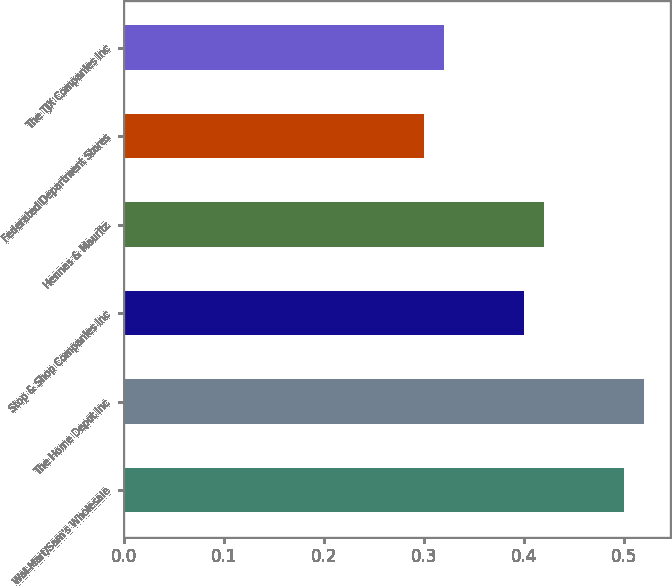<chart> <loc_0><loc_0><loc_500><loc_500><bar_chart><fcel>Wal-Mart/Sam's Wholesale<fcel>The Home Depot Inc<fcel>Stop & Shop Companies Inc<fcel>Hennes & Mauritz<fcel>Federated Department Stores<fcel>The TJX Companies Inc<nl><fcel>0.5<fcel>0.52<fcel>0.4<fcel>0.42<fcel>0.3<fcel>0.32<nl></chart> 